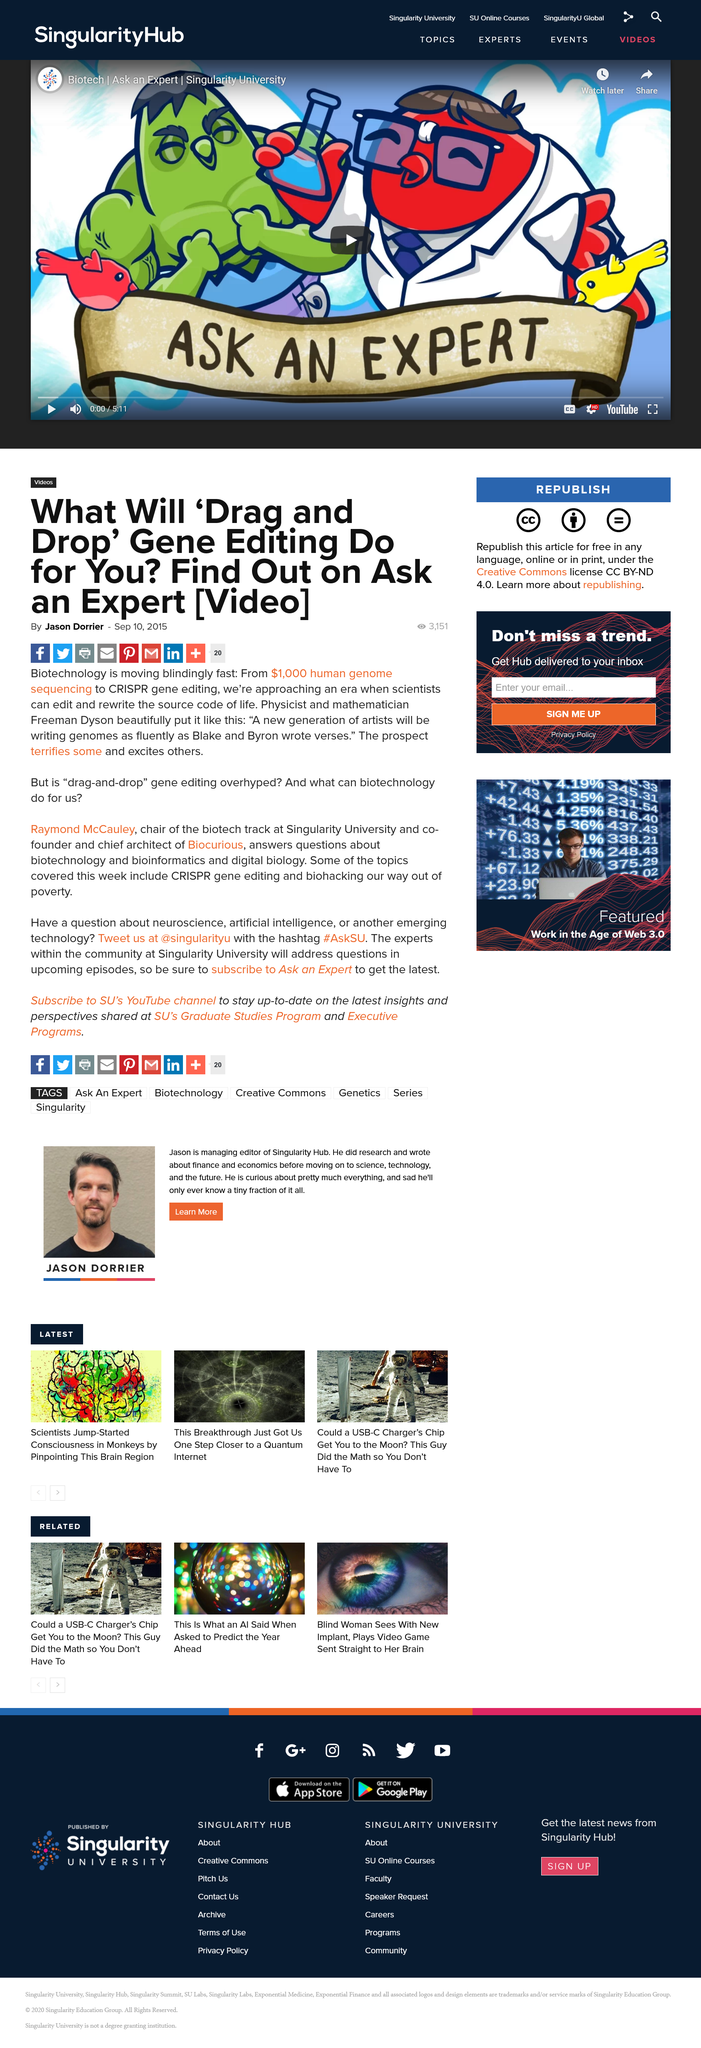Outline some significant characteristics in this image. Experts from within the Singularity University community will be addressing questions in future episodes. Raymond McCauley will be available to answer questions about biotechnology, bioinformatics, and digital biology. Raymond McCauley is the chair of the biotech track at Singularity University and the co-founder and chief architect of Biocurious, a platform that enables scientists to discover and publish their scientific findings. 